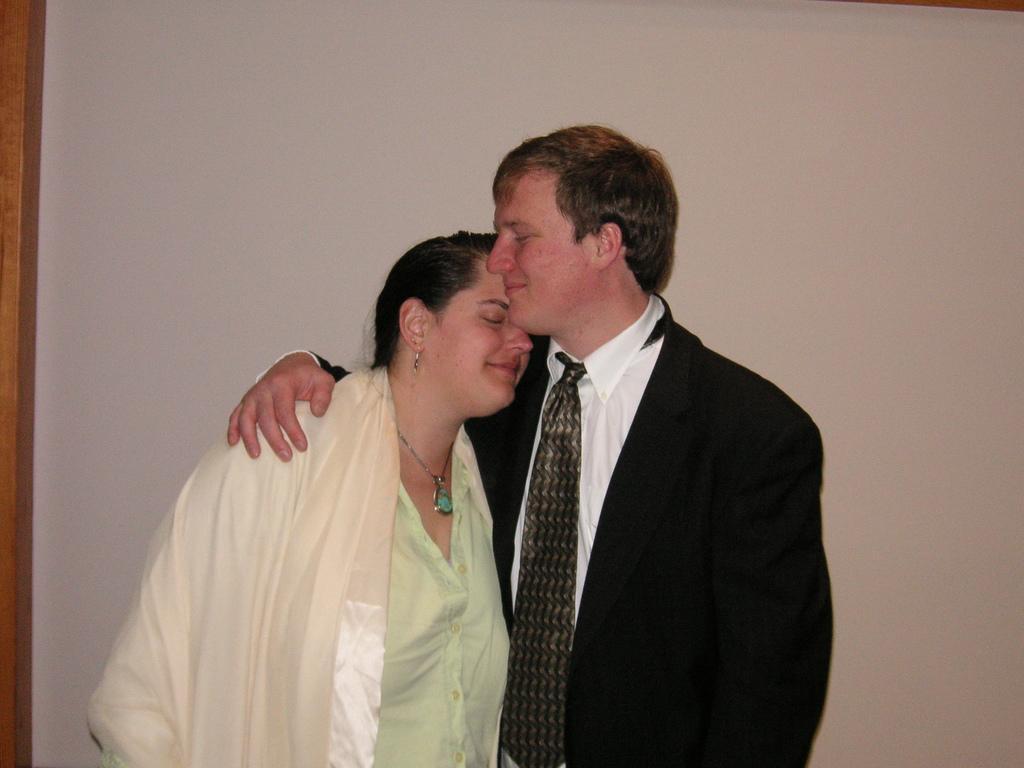How would you summarize this image in a sentence or two? This picture is clicked inside. On the right there is a person wearing suit, tie and standing on the ground. On the left there is a woman smiling and standing. In the background there is a wall and some wooden object. 